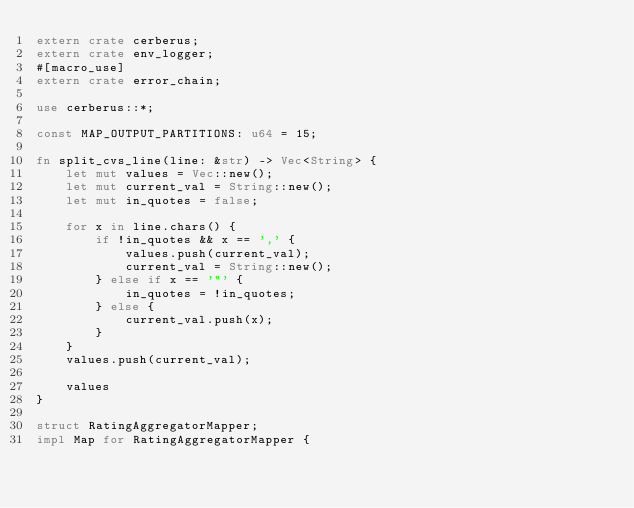Convert code to text. <code><loc_0><loc_0><loc_500><loc_500><_Rust_>extern crate cerberus;
extern crate env_logger;
#[macro_use]
extern crate error_chain;

use cerberus::*;

const MAP_OUTPUT_PARTITIONS: u64 = 15;

fn split_cvs_line(line: &str) -> Vec<String> {
    let mut values = Vec::new();
    let mut current_val = String::new();
    let mut in_quotes = false;

    for x in line.chars() {
        if !in_quotes && x == ',' {
            values.push(current_val);
            current_val = String::new();
        } else if x == '"' {
            in_quotes = !in_quotes;
        } else {
            current_val.push(x);
        }
    }
    values.push(current_val);

    values
}

struct RatingAggregatorMapper;
impl Map for RatingAggregatorMapper {</code> 